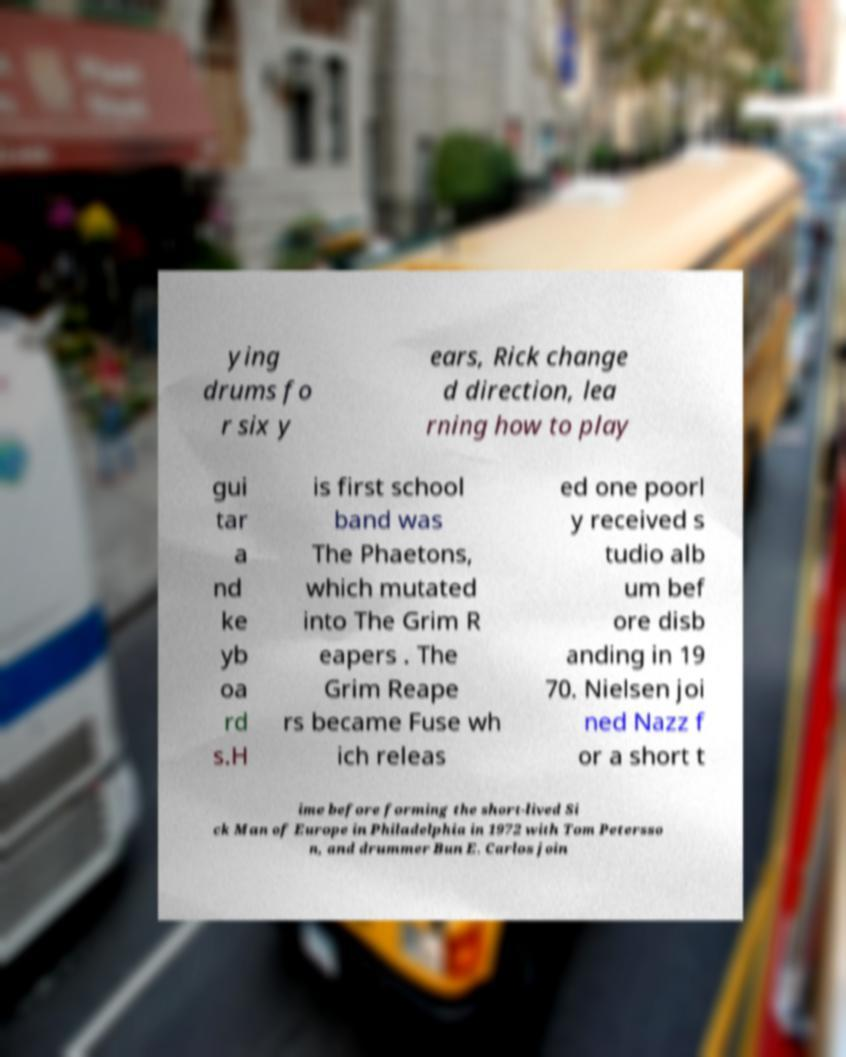For documentation purposes, I need the text within this image transcribed. Could you provide that? ying drums fo r six y ears, Rick change d direction, lea rning how to play gui tar a nd ke yb oa rd s.H is first school band was The Phaetons, which mutated into The Grim R eapers . The Grim Reape rs became Fuse wh ich releas ed one poorl y received s tudio alb um bef ore disb anding in 19 70. Nielsen joi ned Nazz f or a short t ime before forming the short-lived Si ck Man of Europe in Philadelphia in 1972 with Tom Petersso n, and drummer Bun E. Carlos join 